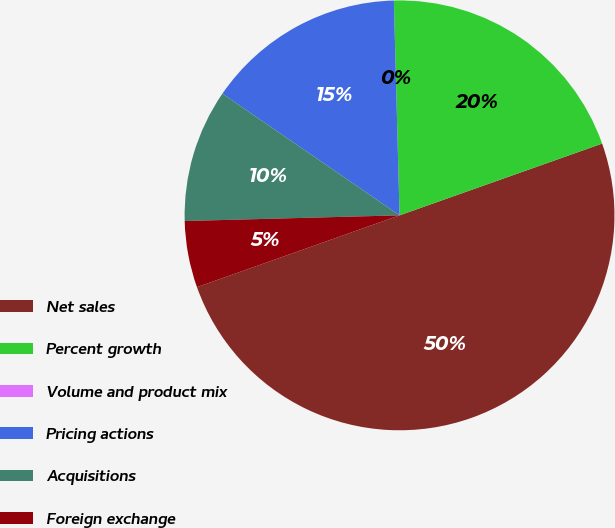Convert chart to OTSL. <chart><loc_0><loc_0><loc_500><loc_500><pie_chart><fcel>Net sales<fcel>Percent growth<fcel>Volume and product mix<fcel>Pricing actions<fcel>Acquisitions<fcel>Foreign exchange<nl><fcel>50.0%<fcel>20.0%<fcel>0.0%<fcel>15.0%<fcel>10.0%<fcel>5.0%<nl></chart> 